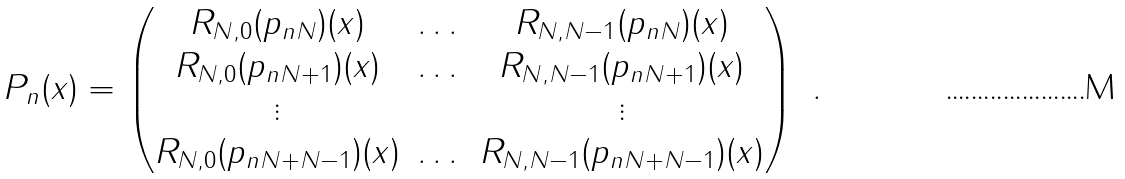Convert formula to latex. <formula><loc_0><loc_0><loc_500><loc_500>P _ { n } ( x ) = \begin{pmatrix} R _ { N , 0 } ( p _ { n N } ) ( x ) & \dots & R _ { N , N - 1 } ( p _ { n N } ) ( x ) \\ R _ { N , 0 } ( p _ { n N + 1 } ) ( x ) & \dots & R _ { N , N - 1 } ( p _ { n N + 1 } ) ( x ) \\ \vdots & & \vdots \\ R _ { N , 0 } ( p _ { n N + N - 1 } ) ( x ) & \dots & R _ { N , N - 1 } ( p _ { n N + N - 1 } ) ( x ) \end{pmatrix} \ .</formula> 